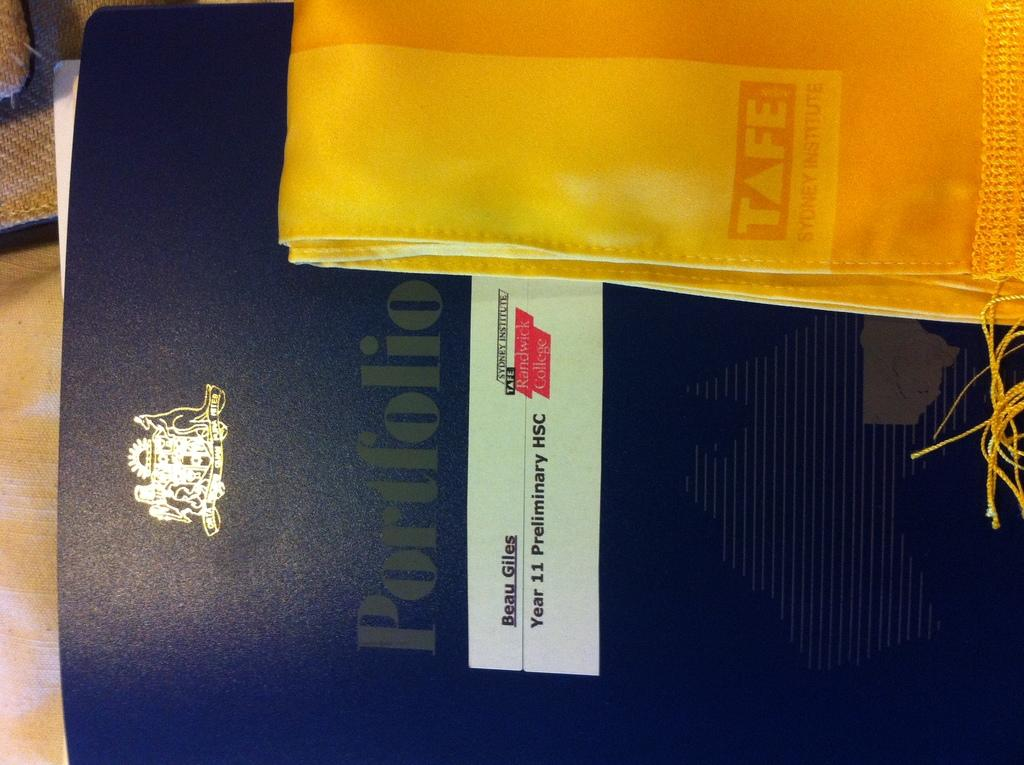<image>
Render a clear and concise summary of the photo. A piece of cloth has the TAFE logo on it. 